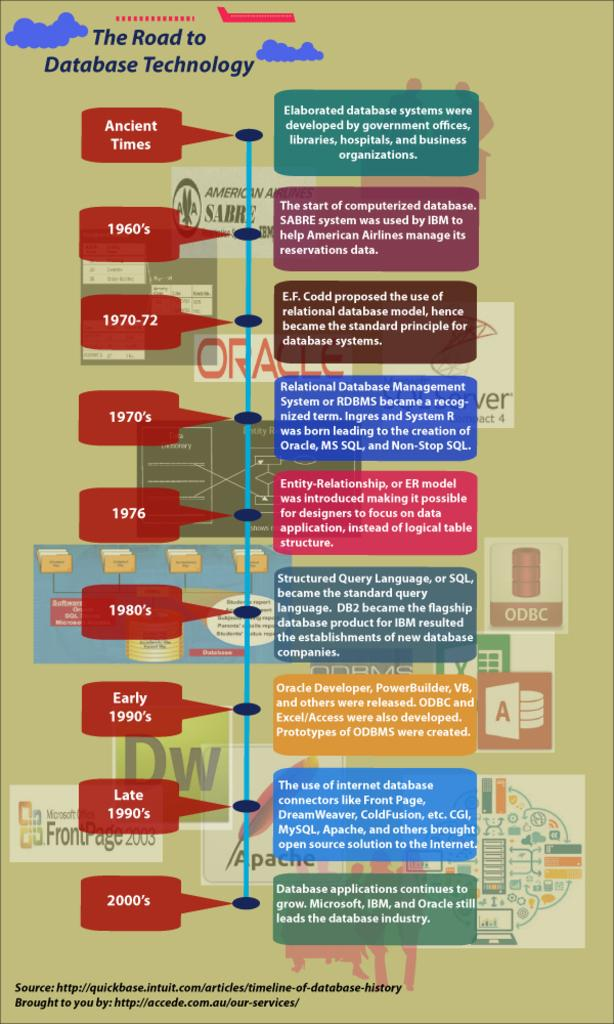<image>
Share a concise interpretation of the image provided. timeline chart for database technology going from ancient times thru the 2000s 